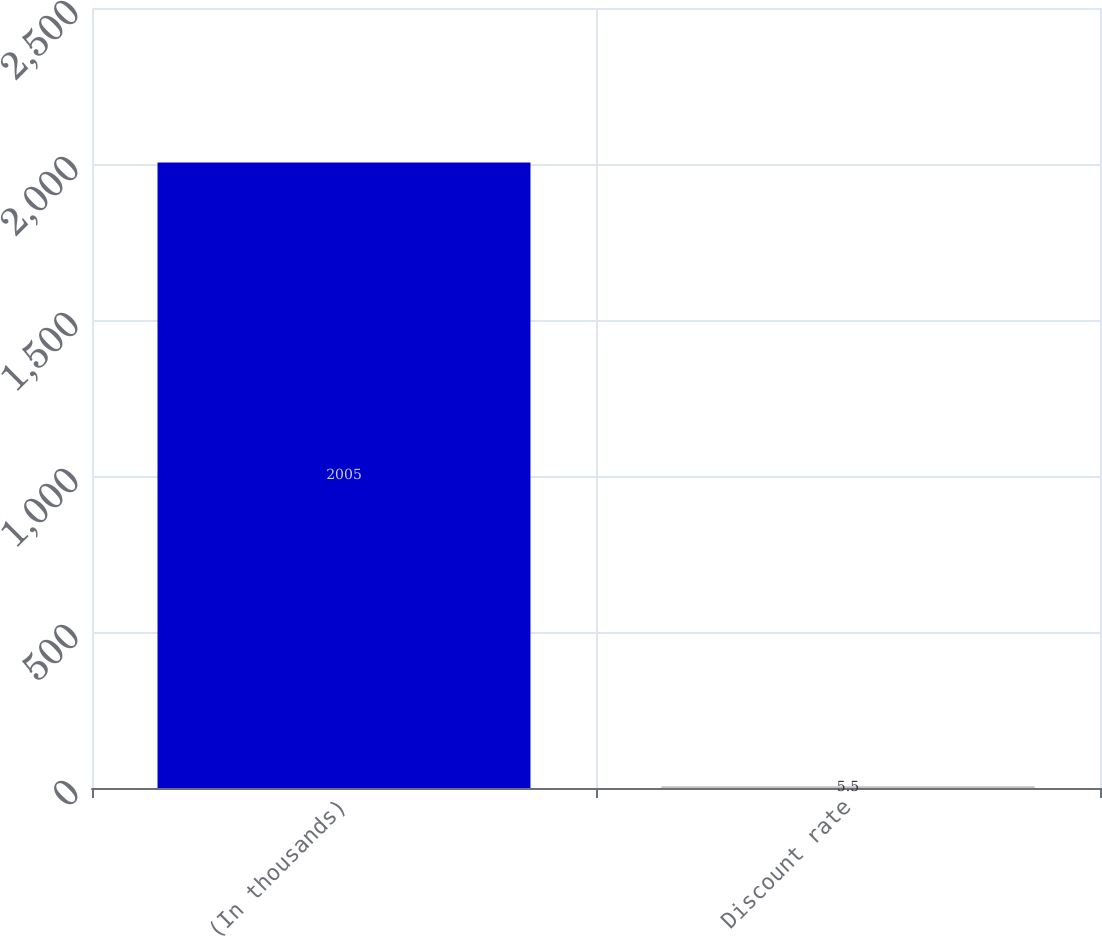<chart> <loc_0><loc_0><loc_500><loc_500><bar_chart><fcel>(In thousands)<fcel>Discount rate<nl><fcel>2005<fcel>5.5<nl></chart> 